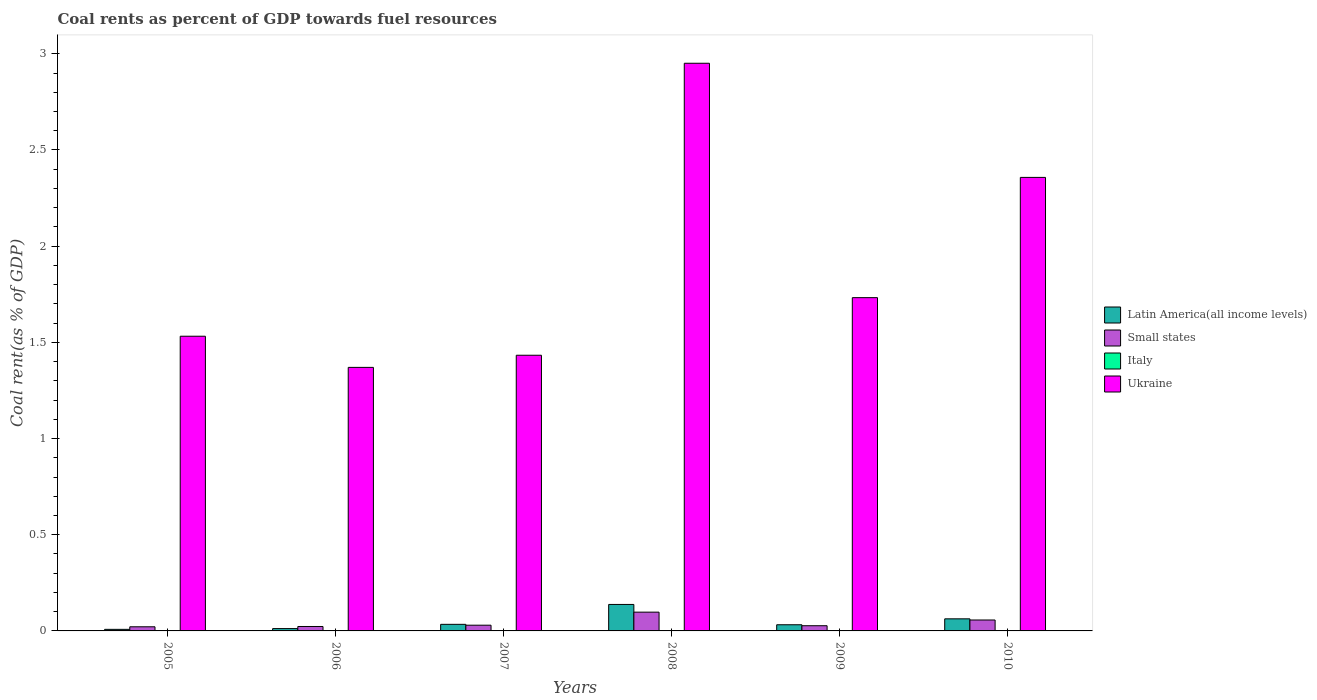How many different coloured bars are there?
Your answer should be compact. 4. How many groups of bars are there?
Give a very brief answer. 6. Are the number of bars on each tick of the X-axis equal?
Provide a short and direct response. Yes. How many bars are there on the 2nd tick from the right?
Make the answer very short. 4. What is the coal rent in Italy in 2010?
Keep it short and to the point. 0. Across all years, what is the maximum coal rent in Latin America(all income levels)?
Offer a terse response. 0.14. Across all years, what is the minimum coal rent in Italy?
Your answer should be very brief. 5.16849671469394e-6. What is the total coal rent in Italy in the graph?
Your response must be concise. 0. What is the difference between the coal rent in Latin America(all income levels) in 2005 and that in 2009?
Offer a very short reply. -0.02. What is the difference between the coal rent in Small states in 2010 and the coal rent in Latin America(all income levels) in 2009?
Offer a very short reply. 0.02. What is the average coal rent in Small states per year?
Offer a very short reply. 0.04. In the year 2005, what is the difference between the coal rent in Latin America(all income levels) and coal rent in Small states?
Give a very brief answer. -0.01. What is the ratio of the coal rent in Small states in 2006 to that in 2008?
Provide a succinct answer. 0.24. Is the coal rent in Ukraine in 2008 less than that in 2009?
Give a very brief answer. No. What is the difference between the highest and the second highest coal rent in Latin America(all income levels)?
Offer a terse response. 0.07. What is the difference between the highest and the lowest coal rent in Italy?
Offer a terse response. 0. Is the sum of the coal rent in Italy in 2005 and 2006 greater than the maximum coal rent in Ukraine across all years?
Offer a terse response. No. Is it the case that in every year, the sum of the coal rent in Latin America(all income levels) and coal rent in Small states is greater than the sum of coal rent in Ukraine and coal rent in Italy?
Your answer should be very brief. No. What does the 2nd bar from the left in 2008 represents?
Provide a succinct answer. Small states. What does the 1st bar from the right in 2007 represents?
Your answer should be compact. Ukraine. Is it the case that in every year, the sum of the coal rent in Ukraine and coal rent in Latin America(all income levels) is greater than the coal rent in Italy?
Offer a very short reply. Yes. How many bars are there?
Offer a terse response. 24. Are all the bars in the graph horizontal?
Ensure brevity in your answer.  No. Are the values on the major ticks of Y-axis written in scientific E-notation?
Your answer should be very brief. No. Where does the legend appear in the graph?
Make the answer very short. Center right. How many legend labels are there?
Your answer should be very brief. 4. What is the title of the graph?
Keep it short and to the point. Coal rents as percent of GDP towards fuel resources. What is the label or title of the X-axis?
Provide a succinct answer. Years. What is the label or title of the Y-axis?
Your answer should be very brief. Coal rent(as % of GDP). What is the Coal rent(as % of GDP) in Latin America(all income levels) in 2005?
Keep it short and to the point. 0.01. What is the Coal rent(as % of GDP) in Small states in 2005?
Provide a short and direct response. 0.02. What is the Coal rent(as % of GDP) of Italy in 2005?
Offer a very short reply. 1.52938665315344e-5. What is the Coal rent(as % of GDP) in Ukraine in 2005?
Provide a short and direct response. 1.53. What is the Coal rent(as % of GDP) in Latin America(all income levels) in 2006?
Offer a terse response. 0.01. What is the Coal rent(as % of GDP) of Small states in 2006?
Provide a succinct answer. 0.02. What is the Coal rent(as % of GDP) in Italy in 2006?
Provide a short and direct response. 5.16849671469394e-6. What is the Coal rent(as % of GDP) in Ukraine in 2006?
Your response must be concise. 1.37. What is the Coal rent(as % of GDP) in Latin America(all income levels) in 2007?
Your answer should be compact. 0.03. What is the Coal rent(as % of GDP) in Small states in 2007?
Provide a succinct answer. 0.03. What is the Coal rent(as % of GDP) in Italy in 2007?
Provide a succinct answer. 0. What is the Coal rent(as % of GDP) of Ukraine in 2007?
Offer a terse response. 1.43. What is the Coal rent(as % of GDP) of Latin America(all income levels) in 2008?
Give a very brief answer. 0.14. What is the Coal rent(as % of GDP) of Small states in 2008?
Your response must be concise. 0.1. What is the Coal rent(as % of GDP) in Italy in 2008?
Your answer should be compact. 0. What is the Coal rent(as % of GDP) in Ukraine in 2008?
Give a very brief answer. 2.95. What is the Coal rent(as % of GDP) in Latin America(all income levels) in 2009?
Your answer should be compact. 0.03. What is the Coal rent(as % of GDP) in Small states in 2009?
Ensure brevity in your answer.  0.03. What is the Coal rent(as % of GDP) in Italy in 2009?
Offer a terse response. 5.380155600468061e-5. What is the Coal rent(as % of GDP) of Ukraine in 2009?
Provide a succinct answer. 1.73. What is the Coal rent(as % of GDP) of Latin America(all income levels) in 2010?
Keep it short and to the point. 0.06. What is the Coal rent(as % of GDP) in Small states in 2010?
Make the answer very short. 0.06. What is the Coal rent(as % of GDP) of Italy in 2010?
Offer a terse response. 0. What is the Coal rent(as % of GDP) in Ukraine in 2010?
Give a very brief answer. 2.36. Across all years, what is the maximum Coal rent(as % of GDP) of Latin America(all income levels)?
Offer a very short reply. 0.14. Across all years, what is the maximum Coal rent(as % of GDP) in Small states?
Make the answer very short. 0.1. Across all years, what is the maximum Coal rent(as % of GDP) of Italy?
Offer a terse response. 0. Across all years, what is the maximum Coal rent(as % of GDP) in Ukraine?
Offer a terse response. 2.95. Across all years, what is the minimum Coal rent(as % of GDP) of Latin America(all income levels)?
Ensure brevity in your answer.  0.01. Across all years, what is the minimum Coal rent(as % of GDP) of Small states?
Offer a very short reply. 0.02. Across all years, what is the minimum Coal rent(as % of GDP) of Italy?
Your response must be concise. 5.16849671469394e-6. Across all years, what is the minimum Coal rent(as % of GDP) of Ukraine?
Your answer should be compact. 1.37. What is the total Coal rent(as % of GDP) in Latin America(all income levels) in the graph?
Provide a short and direct response. 0.29. What is the total Coal rent(as % of GDP) in Small states in the graph?
Keep it short and to the point. 0.26. What is the total Coal rent(as % of GDP) of Italy in the graph?
Provide a succinct answer. 0. What is the total Coal rent(as % of GDP) of Ukraine in the graph?
Offer a very short reply. 11.38. What is the difference between the Coal rent(as % of GDP) of Latin America(all income levels) in 2005 and that in 2006?
Your response must be concise. -0. What is the difference between the Coal rent(as % of GDP) in Small states in 2005 and that in 2006?
Make the answer very short. -0. What is the difference between the Coal rent(as % of GDP) in Ukraine in 2005 and that in 2006?
Give a very brief answer. 0.16. What is the difference between the Coal rent(as % of GDP) of Latin America(all income levels) in 2005 and that in 2007?
Provide a short and direct response. -0.03. What is the difference between the Coal rent(as % of GDP) of Small states in 2005 and that in 2007?
Keep it short and to the point. -0.01. What is the difference between the Coal rent(as % of GDP) of Italy in 2005 and that in 2007?
Give a very brief answer. -0. What is the difference between the Coal rent(as % of GDP) in Ukraine in 2005 and that in 2007?
Make the answer very short. 0.1. What is the difference between the Coal rent(as % of GDP) in Latin America(all income levels) in 2005 and that in 2008?
Your answer should be compact. -0.13. What is the difference between the Coal rent(as % of GDP) of Small states in 2005 and that in 2008?
Your response must be concise. -0.08. What is the difference between the Coal rent(as % of GDP) in Italy in 2005 and that in 2008?
Offer a very short reply. -0. What is the difference between the Coal rent(as % of GDP) in Ukraine in 2005 and that in 2008?
Offer a very short reply. -1.42. What is the difference between the Coal rent(as % of GDP) of Latin America(all income levels) in 2005 and that in 2009?
Your answer should be very brief. -0.02. What is the difference between the Coal rent(as % of GDP) in Small states in 2005 and that in 2009?
Offer a very short reply. -0.01. What is the difference between the Coal rent(as % of GDP) in Italy in 2005 and that in 2009?
Give a very brief answer. -0. What is the difference between the Coal rent(as % of GDP) in Ukraine in 2005 and that in 2009?
Give a very brief answer. -0.2. What is the difference between the Coal rent(as % of GDP) of Latin America(all income levels) in 2005 and that in 2010?
Provide a short and direct response. -0.05. What is the difference between the Coal rent(as % of GDP) in Small states in 2005 and that in 2010?
Ensure brevity in your answer.  -0.04. What is the difference between the Coal rent(as % of GDP) in Italy in 2005 and that in 2010?
Offer a terse response. -0. What is the difference between the Coal rent(as % of GDP) of Ukraine in 2005 and that in 2010?
Give a very brief answer. -0.83. What is the difference between the Coal rent(as % of GDP) of Latin America(all income levels) in 2006 and that in 2007?
Keep it short and to the point. -0.02. What is the difference between the Coal rent(as % of GDP) in Small states in 2006 and that in 2007?
Provide a short and direct response. -0.01. What is the difference between the Coal rent(as % of GDP) of Italy in 2006 and that in 2007?
Offer a very short reply. -0. What is the difference between the Coal rent(as % of GDP) in Ukraine in 2006 and that in 2007?
Ensure brevity in your answer.  -0.06. What is the difference between the Coal rent(as % of GDP) of Latin America(all income levels) in 2006 and that in 2008?
Ensure brevity in your answer.  -0.13. What is the difference between the Coal rent(as % of GDP) in Small states in 2006 and that in 2008?
Ensure brevity in your answer.  -0.07. What is the difference between the Coal rent(as % of GDP) in Italy in 2006 and that in 2008?
Offer a very short reply. -0. What is the difference between the Coal rent(as % of GDP) of Ukraine in 2006 and that in 2008?
Make the answer very short. -1.58. What is the difference between the Coal rent(as % of GDP) of Latin America(all income levels) in 2006 and that in 2009?
Give a very brief answer. -0.02. What is the difference between the Coal rent(as % of GDP) of Small states in 2006 and that in 2009?
Provide a short and direct response. -0. What is the difference between the Coal rent(as % of GDP) of Ukraine in 2006 and that in 2009?
Offer a terse response. -0.36. What is the difference between the Coal rent(as % of GDP) of Latin America(all income levels) in 2006 and that in 2010?
Your answer should be compact. -0.05. What is the difference between the Coal rent(as % of GDP) of Small states in 2006 and that in 2010?
Your answer should be compact. -0.03. What is the difference between the Coal rent(as % of GDP) of Italy in 2006 and that in 2010?
Keep it short and to the point. -0. What is the difference between the Coal rent(as % of GDP) of Ukraine in 2006 and that in 2010?
Give a very brief answer. -0.99. What is the difference between the Coal rent(as % of GDP) of Latin America(all income levels) in 2007 and that in 2008?
Give a very brief answer. -0.1. What is the difference between the Coal rent(as % of GDP) in Small states in 2007 and that in 2008?
Provide a succinct answer. -0.07. What is the difference between the Coal rent(as % of GDP) of Italy in 2007 and that in 2008?
Give a very brief answer. -0. What is the difference between the Coal rent(as % of GDP) in Ukraine in 2007 and that in 2008?
Offer a very short reply. -1.52. What is the difference between the Coal rent(as % of GDP) in Latin America(all income levels) in 2007 and that in 2009?
Provide a short and direct response. 0. What is the difference between the Coal rent(as % of GDP) in Small states in 2007 and that in 2009?
Keep it short and to the point. 0. What is the difference between the Coal rent(as % of GDP) in Ukraine in 2007 and that in 2009?
Your response must be concise. -0.3. What is the difference between the Coal rent(as % of GDP) in Latin America(all income levels) in 2007 and that in 2010?
Make the answer very short. -0.03. What is the difference between the Coal rent(as % of GDP) in Small states in 2007 and that in 2010?
Offer a terse response. -0.03. What is the difference between the Coal rent(as % of GDP) of Italy in 2007 and that in 2010?
Your response must be concise. -0. What is the difference between the Coal rent(as % of GDP) in Ukraine in 2007 and that in 2010?
Provide a short and direct response. -0.92. What is the difference between the Coal rent(as % of GDP) of Latin America(all income levels) in 2008 and that in 2009?
Give a very brief answer. 0.11. What is the difference between the Coal rent(as % of GDP) in Small states in 2008 and that in 2009?
Provide a succinct answer. 0.07. What is the difference between the Coal rent(as % of GDP) in Italy in 2008 and that in 2009?
Provide a succinct answer. 0. What is the difference between the Coal rent(as % of GDP) in Ukraine in 2008 and that in 2009?
Offer a terse response. 1.22. What is the difference between the Coal rent(as % of GDP) of Latin America(all income levels) in 2008 and that in 2010?
Your answer should be compact. 0.07. What is the difference between the Coal rent(as % of GDP) of Small states in 2008 and that in 2010?
Your response must be concise. 0.04. What is the difference between the Coal rent(as % of GDP) of Ukraine in 2008 and that in 2010?
Make the answer very short. 0.59. What is the difference between the Coal rent(as % of GDP) in Latin America(all income levels) in 2009 and that in 2010?
Offer a terse response. -0.03. What is the difference between the Coal rent(as % of GDP) in Small states in 2009 and that in 2010?
Offer a very short reply. -0.03. What is the difference between the Coal rent(as % of GDP) of Italy in 2009 and that in 2010?
Your response must be concise. -0. What is the difference between the Coal rent(as % of GDP) of Ukraine in 2009 and that in 2010?
Your answer should be compact. -0.63. What is the difference between the Coal rent(as % of GDP) of Latin America(all income levels) in 2005 and the Coal rent(as % of GDP) of Small states in 2006?
Ensure brevity in your answer.  -0.01. What is the difference between the Coal rent(as % of GDP) of Latin America(all income levels) in 2005 and the Coal rent(as % of GDP) of Italy in 2006?
Your answer should be compact. 0.01. What is the difference between the Coal rent(as % of GDP) in Latin America(all income levels) in 2005 and the Coal rent(as % of GDP) in Ukraine in 2006?
Ensure brevity in your answer.  -1.36. What is the difference between the Coal rent(as % of GDP) of Small states in 2005 and the Coal rent(as % of GDP) of Italy in 2006?
Your answer should be very brief. 0.02. What is the difference between the Coal rent(as % of GDP) of Small states in 2005 and the Coal rent(as % of GDP) of Ukraine in 2006?
Your answer should be very brief. -1.35. What is the difference between the Coal rent(as % of GDP) of Italy in 2005 and the Coal rent(as % of GDP) of Ukraine in 2006?
Your response must be concise. -1.37. What is the difference between the Coal rent(as % of GDP) in Latin America(all income levels) in 2005 and the Coal rent(as % of GDP) in Small states in 2007?
Offer a terse response. -0.02. What is the difference between the Coal rent(as % of GDP) in Latin America(all income levels) in 2005 and the Coal rent(as % of GDP) in Italy in 2007?
Offer a terse response. 0.01. What is the difference between the Coal rent(as % of GDP) in Latin America(all income levels) in 2005 and the Coal rent(as % of GDP) in Ukraine in 2007?
Offer a very short reply. -1.42. What is the difference between the Coal rent(as % of GDP) in Small states in 2005 and the Coal rent(as % of GDP) in Italy in 2007?
Make the answer very short. 0.02. What is the difference between the Coal rent(as % of GDP) of Small states in 2005 and the Coal rent(as % of GDP) of Ukraine in 2007?
Offer a terse response. -1.41. What is the difference between the Coal rent(as % of GDP) in Italy in 2005 and the Coal rent(as % of GDP) in Ukraine in 2007?
Provide a succinct answer. -1.43. What is the difference between the Coal rent(as % of GDP) of Latin America(all income levels) in 2005 and the Coal rent(as % of GDP) of Small states in 2008?
Keep it short and to the point. -0.09. What is the difference between the Coal rent(as % of GDP) of Latin America(all income levels) in 2005 and the Coal rent(as % of GDP) of Italy in 2008?
Give a very brief answer. 0.01. What is the difference between the Coal rent(as % of GDP) of Latin America(all income levels) in 2005 and the Coal rent(as % of GDP) of Ukraine in 2008?
Offer a terse response. -2.94. What is the difference between the Coal rent(as % of GDP) of Small states in 2005 and the Coal rent(as % of GDP) of Italy in 2008?
Provide a short and direct response. 0.02. What is the difference between the Coal rent(as % of GDP) of Small states in 2005 and the Coal rent(as % of GDP) of Ukraine in 2008?
Your answer should be very brief. -2.93. What is the difference between the Coal rent(as % of GDP) of Italy in 2005 and the Coal rent(as % of GDP) of Ukraine in 2008?
Make the answer very short. -2.95. What is the difference between the Coal rent(as % of GDP) in Latin America(all income levels) in 2005 and the Coal rent(as % of GDP) in Small states in 2009?
Offer a very short reply. -0.02. What is the difference between the Coal rent(as % of GDP) of Latin America(all income levels) in 2005 and the Coal rent(as % of GDP) of Italy in 2009?
Your answer should be very brief. 0.01. What is the difference between the Coal rent(as % of GDP) of Latin America(all income levels) in 2005 and the Coal rent(as % of GDP) of Ukraine in 2009?
Provide a short and direct response. -1.72. What is the difference between the Coal rent(as % of GDP) of Small states in 2005 and the Coal rent(as % of GDP) of Italy in 2009?
Offer a very short reply. 0.02. What is the difference between the Coal rent(as % of GDP) of Small states in 2005 and the Coal rent(as % of GDP) of Ukraine in 2009?
Give a very brief answer. -1.71. What is the difference between the Coal rent(as % of GDP) in Italy in 2005 and the Coal rent(as % of GDP) in Ukraine in 2009?
Offer a very short reply. -1.73. What is the difference between the Coal rent(as % of GDP) in Latin America(all income levels) in 2005 and the Coal rent(as % of GDP) in Small states in 2010?
Give a very brief answer. -0.05. What is the difference between the Coal rent(as % of GDP) of Latin America(all income levels) in 2005 and the Coal rent(as % of GDP) of Italy in 2010?
Your answer should be compact. 0.01. What is the difference between the Coal rent(as % of GDP) of Latin America(all income levels) in 2005 and the Coal rent(as % of GDP) of Ukraine in 2010?
Your response must be concise. -2.35. What is the difference between the Coal rent(as % of GDP) in Small states in 2005 and the Coal rent(as % of GDP) in Italy in 2010?
Provide a succinct answer. 0.02. What is the difference between the Coal rent(as % of GDP) of Small states in 2005 and the Coal rent(as % of GDP) of Ukraine in 2010?
Provide a short and direct response. -2.34. What is the difference between the Coal rent(as % of GDP) of Italy in 2005 and the Coal rent(as % of GDP) of Ukraine in 2010?
Offer a very short reply. -2.36. What is the difference between the Coal rent(as % of GDP) of Latin America(all income levels) in 2006 and the Coal rent(as % of GDP) of Small states in 2007?
Your response must be concise. -0.02. What is the difference between the Coal rent(as % of GDP) in Latin America(all income levels) in 2006 and the Coal rent(as % of GDP) in Italy in 2007?
Make the answer very short. 0.01. What is the difference between the Coal rent(as % of GDP) in Latin America(all income levels) in 2006 and the Coal rent(as % of GDP) in Ukraine in 2007?
Ensure brevity in your answer.  -1.42. What is the difference between the Coal rent(as % of GDP) of Small states in 2006 and the Coal rent(as % of GDP) of Italy in 2007?
Make the answer very short. 0.02. What is the difference between the Coal rent(as % of GDP) in Small states in 2006 and the Coal rent(as % of GDP) in Ukraine in 2007?
Make the answer very short. -1.41. What is the difference between the Coal rent(as % of GDP) of Italy in 2006 and the Coal rent(as % of GDP) of Ukraine in 2007?
Provide a short and direct response. -1.43. What is the difference between the Coal rent(as % of GDP) of Latin America(all income levels) in 2006 and the Coal rent(as % of GDP) of Small states in 2008?
Offer a very short reply. -0.09. What is the difference between the Coal rent(as % of GDP) in Latin America(all income levels) in 2006 and the Coal rent(as % of GDP) in Italy in 2008?
Make the answer very short. 0.01. What is the difference between the Coal rent(as % of GDP) of Latin America(all income levels) in 2006 and the Coal rent(as % of GDP) of Ukraine in 2008?
Your response must be concise. -2.94. What is the difference between the Coal rent(as % of GDP) in Small states in 2006 and the Coal rent(as % of GDP) in Italy in 2008?
Offer a terse response. 0.02. What is the difference between the Coal rent(as % of GDP) in Small states in 2006 and the Coal rent(as % of GDP) in Ukraine in 2008?
Provide a short and direct response. -2.93. What is the difference between the Coal rent(as % of GDP) in Italy in 2006 and the Coal rent(as % of GDP) in Ukraine in 2008?
Give a very brief answer. -2.95. What is the difference between the Coal rent(as % of GDP) of Latin America(all income levels) in 2006 and the Coal rent(as % of GDP) of Small states in 2009?
Provide a short and direct response. -0.01. What is the difference between the Coal rent(as % of GDP) of Latin America(all income levels) in 2006 and the Coal rent(as % of GDP) of Italy in 2009?
Make the answer very short. 0.01. What is the difference between the Coal rent(as % of GDP) in Latin America(all income levels) in 2006 and the Coal rent(as % of GDP) in Ukraine in 2009?
Your response must be concise. -1.72. What is the difference between the Coal rent(as % of GDP) of Small states in 2006 and the Coal rent(as % of GDP) of Italy in 2009?
Offer a very short reply. 0.02. What is the difference between the Coal rent(as % of GDP) of Small states in 2006 and the Coal rent(as % of GDP) of Ukraine in 2009?
Your response must be concise. -1.71. What is the difference between the Coal rent(as % of GDP) of Italy in 2006 and the Coal rent(as % of GDP) of Ukraine in 2009?
Give a very brief answer. -1.73. What is the difference between the Coal rent(as % of GDP) in Latin America(all income levels) in 2006 and the Coal rent(as % of GDP) in Small states in 2010?
Offer a terse response. -0.04. What is the difference between the Coal rent(as % of GDP) in Latin America(all income levels) in 2006 and the Coal rent(as % of GDP) in Italy in 2010?
Ensure brevity in your answer.  0.01. What is the difference between the Coal rent(as % of GDP) of Latin America(all income levels) in 2006 and the Coal rent(as % of GDP) of Ukraine in 2010?
Your response must be concise. -2.35. What is the difference between the Coal rent(as % of GDP) of Small states in 2006 and the Coal rent(as % of GDP) of Italy in 2010?
Your response must be concise. 0.02. What is the difference between the Coal rent(as % of GDP) of Small states in 2006 and the Coal rent(as % of GDP) of Ukraine in 2010?
Ensure brevity in your answer.  -2.33. What is the difference between the Coal rent(as % of GDP) in Italy in 2006 and the Coal rent(as % of GDP) in Ukraine in 2010?
Ensure brevity in your answer.  -2.36. What is the difference between the Coal rent(as % of GDP) in Latin America(all income levels) in 2007 and the Coal rent(as % of GDP) in Small states in 2008?
Provide a short and direct response. -0.06. What is the difference between the Coal rent(as % of GDP) of Latin America(all income levels) in 2007 and the Coal rent(as % of GDP) of Italy in 2008?
Your response must be concise. 0.03. What is the difference between the Coal rent(as % of GDP) in Latin America(all income levels) in 2007 and the Coal rent(as % of GDP) in Ukraine in 2008?
Your response must be concise. -2.92. What is the difference between the Coal rent(as % of GDP) of Small states in 2007 and the Coal rent(as % of GDP) of Italy in 2008?
Provide a succinct answer. 0.03. What is the difference between the Coal rent(as % of GDP) in Small states in 2007 and the Coal rent(as % of GDP) in Ukraine in 2008?
Offer a very short reply. -2.92. What is the difference between the Coal rent(as % of GDP) in Italy in 2007 and the Coal rent(as % of GDP) in Ukraine in 2008?
Ensure brevity in your answer.  -2.95. What is the difference between the Coal rent(as % of GDP) in Latin America(all income levels) in 2007 and the Coal rent(as % of GDP) in Small states in 2009?
Provide a short and direct response. 0.01. What is the difference between the Coal rent(as % of GDP) of Latin America(all income levels) in 2007 and the Coal rent(as % of GDP) of Italy in 2009?
Ensure brevity in your answer.  0.03. What is the difference between the Coal rent(as % of GDP) of Latin America(all income levels) in 2007 and the Coal rent(as % of GDP) of Ukraine in 2009?
Keep it short and to the point. -1.7. What is the difference between the Coal rent(as % of GDP) of Small states in 2007 and the Coal rent(as % of GDP) of Italy in 2009?
Your answer should be compact. 0.03. What is the difference between the Coal rent(as % of GDP) of Small states in 2007 and the Coal rent(as % of GDP) of Ukraine in 2009?
Give a very brief answer. -1.7. What is the difference between the Coal rent(as % of GDP) of Italy in 2007 and the Coal rent(as % of GDP) of Ukraine in 2009?
Your answer should be compact. -1.73. What is the difference between the Coal rent(as % of GDP) of Latin America(all income levels) in 2007 and the Coal rent(as % of GDP) of Small states in 2010?
Your answer should be compact. -0.02. What is the difference between the Coal rent(as % of GDP) of Latin America(all income levels) in 2007 and the Coal rent(as % of GDP) of Italy in 2010?
Keep it short and to the point. 0.03. What is the difference between the Coal rent(as % of GDP) in Latin America(all income levels) in 2007 and the Coal rent(as % of GDP) in Ukraine in 2010?
Offer a terse response. -2.32. What is the difference between the Coal rent(as % of GDP) in Small states in 2007 and the Coal rent(as % of GDP) in Italy in 2010?
Ensure brevity in your answer.  0.03. What is the difference between the Coal rent(as % of GDP) of Small states in 2007 and the Coal rent(as % of GDP) of Ukraine in 2010?
Keep it short and to the point. -2.33. What is the difference between the Coal rent(as % of GDP) of Italy in 2007 and the Coal rent(as % of GDP) of Ukraine in 2010?
Your response must be concise. -2.36. What is the difference between the Coal rent(as % of GDP) of Latin America(all income levels) in 2008 and the Coal rent(as % of GDP) of Small states in 2009?
Your answer should be compact. 0.11. What is the difference between the Coal rent(as % of GDP) of Latin America(all income levels) in 2008 and the Coal rent(as % of GDP) of Italy in 2009?
Your answer should be very brief. 0.14. What is the difference between the Coal rent(as % of GDP) in Latin America(all income levels) in 2008 and the Coal rent(as % of GDP) in Ukraine in 2009?
Provide a short and direct response. -1.59. What is the difference between the Coal rent(as % of GDP) in Small states in 2008 and the Coal rent(as % of GDP) in Italy in 2009?
Give a very brief answer. 0.1. What is the difference between the Coal rent(as % of GDP) in Small states in 2008 and the Coal rent(as % of GDP) in Ukraine in 2009?
Keep it short and to the point. -1.63. What is the difference between the Coal rent(as % of GDP) of Italy in 2008 and the Coal rent(as % of GDP) of Ukraine in 2009?
Your answer should be compact. -1.73. What is the difference between the Coal rent(as % of GDP) in Latin America(all income levels) in 2008 and the Coal rent(as % of GDP) in Small states in 2010?
Give a very brief answer. 0.08. What is the difference between the Coal rent(as % of GDP) of Latin America(all income levels) in 2008 and the Coal rent(as % of GDP) of Italy in 2010?
Ensure brevity in your answer.  0.14. What is the difference between the Coal rent(as % of GDP) in Latin America(all income levels) in 2008 and the Coal rent(as % of GDP) in Ukraine in 2010?
Offer a very short reply. -2.22. What is the difference between the Coal rent(as % of GDP) of Small states in 2008 and the Coal rent(as % of GDP) of Italy in 2010?
Your answer should be compact. 0.1. What is the difference between the Coal rent(as % of GDP) in Small states in 2008 and the Coal rent(as % of GDP) in Ukraine in 2010?
Your answer should be compact. -2.26. What is the difference between the Coal rent(as % of GDP) of Italy in 2008 and the Coal rent(as % of GDP) of Ukraine in 2010?
Ensure brevity in your answer.  -2.36. What is the difference between the Coal rent(as % of GDP) in Latin America(all income levels) in 2009 and the Coal rent(as % of GDP) in Small states in 2010?
Give a very brief answer. -0.02. What is the difference between the Coal rent(as % of GDP) of Latin America(all income levels) in 2009 and the Coal rent(as % of GDP) of Italy in 2010?
Offer a terse response. 0.03. What is the difference between the Coal rent(as % of GDP) of Latin America(all income levels) in 2009 and the Coal rent(as % of GDP) of Ukraine in 2010?
Your answer should be compact. -2.33. What is the difference between the Coal rent(as % of GDP) of Small states in 2009 and the Coal rent(as % of GDP) of Italy in 2010?
Offer a terse response. 0.03. What is the difference between the Coal rent(as % of GDP) in Small states in 2009 and the Coal rent(as % of GDP) in Ukraine in 2010?
Keep it short and to the point. -2.33. What is the difference between the Coal rent(as % of GDP) in Italy in 2009 and the Coal rent(as % of GDP) in Ukraine in 2010?
Provide a succinct answer. -2.36. What is the average Coal rent(as % of GDP) in Latin America(all income levels) per year?
Make the answer very short. 0.05. What is the average Coal rent(as % of GDP) of Small states per year?
Provide a succinct answer. 0.04. What is the average Coal rent(as % of GDP) in Ukraine per year?
Give a very brief answer. 1.9. In the year 2005, what is the difference between the Coal rent(as % of GDP) of Latin America(all income levels) and Coal rent(as % of GDP) of Small states?
Keep it short and to the point. -0.01. In the year 2005, what is the difference between the Coal rent(as % of GDP) in Latin America(all income levels) and Coal rent(as % of GDP) in Italy?
Give a very brief answer. 0.01. In the year 2005, what is the difference between the Coal rent(as % of GDP) of Latin America(all income levels) and Coal rent(as % of GDP) of Ukraine?
Your answer should be compact. -1.52. In the year 2005, what is the difference between the Coal rent(as % of GDP) of Small states and Coal rent(as % of GDP) of Italy?
Your response must be concise. 0.02. In the year 2005, what is the difference between the Coal rent(as % of GDP) in Small states and Coal rent(as % of GDP) in Ukraine?
Your response must be concise. -1.51. In the year 2005, what is the difference between the Coal rent(as % of GDP) in Italy and Coal rent(as % of GDP) in Ukraine?
Give a very brief answer. -1.53. In the year 2006, what is the difference between the Coal rent(as % of GDP) in Latin America(all income levels) and Coal rent(as % of GDP) in Small states?
Offer a terse response. -0.01. In the year 2006, what is the difference between the Coal rent(as % of GDP) of Latin America(all income levels) and Coal rent(as % of GDP) of Italy?
Your answer should be compact. 0.01. In the year 2006, what is the difference between the Coal rent(as % of GDP) of Latin America(all income levels) and Coal rent(as % of GDP) of Ukraine?
Give a very brief answer. -1.36. In the year 2006, what is the difference between the Coal rent(as % of GDP) of Small states and Coal rent(as % of GDP) of Italy?
Make the answer very short. 0.02. In the year 2006, what is the difference between the Coal rent(as % of GDP) of Small states and Coal rent(as % of GDP) of Ukraine?
Ensure brevity in your answer.  -1.35. In the year 2006, what is the difference between the Coal rent(as % of GDP) in Italy and Coal rent(as % of GDP) in Ukraine?
Provide a short and direct response. -1.37. In the year 2007, what is the difference between the Coal rent(as % of GDP) of Latin America(all income levels) and Coal rent(as % of GDP) of Small states?
Your answer should be very brief. 0. In the year 2007, what is the difference between the Coal rent(as % of GDP) in Latin America(all income levels) and Coal rent(as % of GDP) in Italy?
Keep it short and to the point. 0.03. In the year 2007, what is the difference between the Coal rent(as % of GDP) in Latin America(all income levels) and Coal rent(as % of GDP) in Ukraine?
Offer a very short reply. -1.4. In the year 2007, what is the difference between the Coal rent(as % of GDP) in Small states and Coal rent(as % of GDP) in Italy?
Offer a very short reply. 0.03. In the year 2007, what is the difference between the Coal rent(as % of GDP) in Small states and Coal rent(as % of GDP) in Ukraine?
Provide a short and direct response. -1.4. In the year 2007, what is the difference between the Coal rent(as % of GDP) in Italy and Coal rent(as % of GDP) in Ukraine?
Make the answer very short. -1.43. In the year 2008, what is the difference between the Coal rent(as % of GDP) of Latin America(all income levels) and Coal rent(as % of GDP) of Italy?
Offer a very short reply. 0.14. In the year 2008, what is the difference between the Coal rent(as % of GDP) in Latin America(all income levels) and Coal rent(as % of GDP) in Ukraine?
Ensure brevity in your answer.  -2.81. In the year 2008, what is the difference between the Coal rent(as % of GDP) of Small states and Coal rent(as % of GDP) of Italy?
Provide a succinct answer. 0.1. In the year 2008, what is the difference between the Coal rent(as % of GDP) in Small states and Coal rent(as % of GDP) in Ukraine?
Provide a succinct answer. -2.85. In the year 2008, what is the difference between the Coal rent(as % of GDP) in Italy and Coal rent(as % of GDP) in Ukraine?
Offer a very short reply. -2.95. In the year 2009, what is the difference between the Coal rent(as % of GDP) in Latin America(all income levels) and Coal rent(as % of GDP) in Small states?
Your response must be concise. 0.01. In the year 2009, what is the difference between the Coal rent(as % of GDP) of Latin America(all income levels) and Coal rent(as % of GDP) of Italy?
Provide a short and direct response. 0.03. In the year 2009, what is the difference between the Coal rent(as % of GDP) in Latin America(all income levels) and Coal rent(as % of GDP) in Ukraine?
Ensure brevity in your answer.  -1.7. In the year 2009, what is the difference between the Coal rent(as % of GDP) in Small states and Coal rent(as % of GDP) in Italy?
Your answer should be compact. 0.03. In the year 2009, what is the difference between the Coal rent(as % of GDP) in Small states and Coal rent(as % of GDP) in Ukraine?
Make the answer very short. -1.71. In the year 2009, what is the difference between the Coal rent(as % of GDP) of Italy and Coal rent(as % of GDP) of Ukraine?
Offer a very short reply. -1.73. In the year 2010, what is the difference between the Coal rent(as % of GDP) of Latin America(all income levels) and Coal rent(as % of GDP) of Small states?
Make the answer very short. 0.01. In the year 2010, what is the difference between the Coal rent(as % of GDP) of Latin America(all income levels) and Coal rent(as % of GDP) of Italy?
Your response must be concise. 0.06. In the year 2010, what is the difference between the Coal rent(as % of GDP) of Latin America(all income levels) and Coal rent(as % of GDP) of Ukraine?
Your answer should be compact. -2.29. In the year 2010, what is the difference between the Coal rent(as % of GDP) of Small states and Coal rent(as % of GDP) of Italy?
Your answer should be very brief. 0.06. In the year 2010, what is the difference between the Coal rent(as % of GDP) in Small states and Coal rent(as % of GDP) in Ukraine?
Keep it short and to the point. -2.3. In the year 2010, what is the difference between the Coal rent(as % of GDP) of Italy and Coal rent(as % of GDP) of Ukraine?
Provide a short and direct response. -2.36. What is the ratio of the Coal rent(as % of GDP) in Latin America(all income levels) in 2005 to that in 2006?
Ensure brevity in your answer.  0.67. What is the ratio of the Coal rent(as % of GDP) of Small states in 2005 to that in 2006?
Ensure brevity in your answer.  0.93. What is the ratio of the Coal rent(as % of GDP) of Italy in 2005 to that in 2006?
Keep it short and to the point. 2.96. What is the ratio of the Coal rent(as % of GDP) of Ukraine in 2005 to that in 2006?
Offer a very short reply. 1.12. What is the ratio of the Coal rent(as % of GDP) of Latin America(all income levels) in 2005 to that in 2007?
Your answer should be compact. 0.24. What is the ratio of the Coal rent(as % of GDP) of Small states in 2005 to that in 2007?
Give a very brief answer. 0.72. What is the ratio of the Coal rent(as % of GDP) of Italy in 2005 to that in 2007?
Offer a very short reply. 0.14. What is the ratio of the Coal rent(as % of GDP) in Ukraine in 2005 to that in 2007?
Ensure brevity in your answer.  1.07. What is the ratio of the Coal rent(as % of GDP) of Latin America(all income levels) in 2005 to that in 2008?
Offer a very short reply. 0.06. What is the ratio of the Coal rent(as % of GDP) of Small states in 2005 to that in 2008?
Offer a very short reply. 0.22. What is the ratio of the Coal rent(as % of GDP) of Italy in 2005 to that in 2008?
Provide a succinct answer. 0.04. What is the ratio of the Coal rent(as % of GDP) in Ukraine in 2005 to that in 2008?
Provide a short and direct response. 0.52. What is the ratio of the Coal rent(as % of GDP) in Latin America(all income levels) in 2005 to that in 2009?
Your response must be concise. 0.26. What is the ratio of the Coal rent(as % of GDP) of Small states in 2005 to that in 2009?
Your answer should be compact. 0.8. What is the ratio of the Coal rent(as % of GDP) of Italy in 2005 to that in 2009?
Offer a terse response. 0.28. What is the ratio of the Coal rent(as % of GDP) of Ukraine in 2005 to that in 2009?
Offer a terse response. 0.88. What is the ratio of the Coal rent(as % of GDP) in Latin America(all income levels) in 2005 to that in 2010?
Keep it short and to the point. 0.13. What is the ratio of the Coal rent(as % of GDP) in Small states in 2005 to that in 2010?
Make the answer very short. 0.38. What is the ratio of the Coal rent(as % of GDP) of Italy in 2005 to that in 2010?
Make the answer very short. 0.08. What is the ratio of the Coal rent(as % of GDP) of Ukraine in 2005 to that in 2010?
Offer a terse response. 0.65. What is the ratio of the Coal rent(as % of GDP) in Latin America(all income levels) in 2006 to that in 2007?
Keep it short and to the point. 0.36. What is the ratio of the Coal rent(as % of GDP) of Small states in 2006 to that in 2007?
Your answer should be very brief. 0.77. What is the ratio of the Coal rent(as % of GDP) in Italy in 2006 to that in 2007?
Provide a short and direct response. 0.05. What is the ratio of the Coal rent(as % of GDP) of Ukraine in 2006 to that in 2007?
Your answer should be very brief. 0.96. What is the ratio of the Coal rent(as % of GDP) of Latin America(all income levels) in 2006 to that in 2008?
Your response must be concise. 0.09. What is the ratio of the Coal rent(as % of GDP) of Small states in 2006 to that in 2008?
Your answer should be compact. 0.24. What is the ratio of the Coal rent(as % of GDP) of Italy in 2006 to that in 2008?
Offer a terse response. 0.01. What is the ratio of the Coal rent(as % of GDP) in Ukraine in 2006 to that in 2008?
Your answer should be very brief. 0.46. What is the ratio of the Coal rent(as % of GDP) in Latin America(all income levels) in 2006 to that in 2009?
Your answer should be compact. 0.38. What is the ratio of the Coal rent(as % of GDP) of Small states in 2006 to that in 2009?
Your answer should be compact. 0.85. What is the ratio of the Coal rent(as % of GDP) of Italy in 2006 to that in 2009?
Offer a very short reply. 0.1. What is the ratio of the Coal rent(as % of GDP) in Ukraine in 2006 to that in 2009?
Provide a succinct answer. 0.79. What is the ratio of the Coal rent(as % of GDP) in Latin America(all income levels) in 2006 to that in 2010?
Your response must be concise. 0.19. What is the ratio of the Coal rent(as % of GDP) in Small states in 2006 to that in 2010?
Offer a terse response. 0.41. What is the ratio of the Coal rent(as % of GDP) in Italy in 2006 to that in 2010?
Your response must be concise. 0.03. What is the ratio of the Coal rent(as % of GDP) in Ukraine in 2006 to that in 2010?
Your answer should be compact. 0.58. What is the ratio of the Coal rent(as % of GDP) in Latin America(all income levels) in 2007 to that in 2008?
Keep it short and to the point. 0.25. What is the ratio of the Coal rent(as % of GDP) in Small states in 2007 to that in 2008?
Your answer should be compact. 0.31. What is the ratio of the Coal rent(as % of GDP) in Italy in 2007 to that in 2008?
Ensure brevity in your answer.  0.32. What is the ratio of the Coal rent(as % of GDP) of Ukraine in 2007 to that in 2008?
Give a very brief answer. 0.49. What is the ratio of the Coal rent(as % of GDP) of Latin America(all income levels) in 2007 to that in 2009?
Offer a very short reply. 1.07. What is the ratio of the Coal rent(as % of GDP) in Small states in 2007 to that in 2009?
Your answer should be compact. 1.1. What is the ratio of the Coal rent(as % of GDP) in Italy in 2007 to that in 2009?
Your response must be concise. 2.07. What is the ratio of the Coal rent(as % of GDP) in Ukraine in 2007 to that in 2009?
Offer a terse response. 0.83. What is the ratio of the Coal rent(as % of GDP) of Latin America(all income levels) in 2007 to that in 2010?
Keep it short and to the point. 0.54. What is the ratio of the Coal rent(as % of GDP) in Small states in 2007 to that in 2010?
Your response must be concise. 0.52. What is the ratio of the Coal rent(as % of GDP) in Italy in 2007 to that in 2010?
Your answer should be compact. 0.6. What is the ratio of the Coal rent(as % of GDP) of Ukraine in 2007 to that in 2010?
Keep it short and to the point. 0.61. What is the ratio of the Coal rent(as % of GDP) in Latin America(all income levels) in 2008 to that in 2009?
Your response must be concise. 4.3. What is the ratio of the Coal rent(as % of GDP) of Small states in 2008 to that in 2009?
Give a very brief answer. 3.61. What is the ratio of the Coal rent(as % of GDP) in Italy in 2008 to that in 2009?
Provide a short and direct response. 6.54. What is the ratio of the Coal rent(as % of GDP) of Ukraine in 2008 to that in 2009?
Provide a short and direct response. 1.7. What is the ratio of the Coal rent(as % of GDP) in Latin America(all income levels) in 2008 to that in 2010?
Offer a terse response. 2.19. What is the ratio of the Coal rent(as % of GDP) of Small states in 2008 to that in 2010?
Your answer should be very brief. 1.72. What is the ratio of the Coal rent(as % of GDP) of Italy in 2008 to that in 2010?
Provide a succinct answer. 1.89. What is the ratio of the Coal rent(as % of GDP) in Ukraine in 2008 to that in 2010?
Make the answer very short. 1.25. What is the ratio of the Coal rent(as % of GDP) of Latin America(all income levels) in 2009 to that in 2010?
Your response must be concise. 0.51. What is the ratio of the Coal rent(as % of GDP) in Small states in 2009 to that in 2010?
Your answer should be compact. 0.48. What is the ratio of the Coal rent(as % of GDP) in Italy in 2009 to that in 2010?
Provide a short and direct response. 0.29. What is the ratio of the Coal rent(as % of GDP) of Ukraine in 2009 to that in 2010?
Make the answer very short. 0.73. What is the difference between the highest and the second highest Coal rent(as % of GDP) in Latin America(all income levels)?
Keep it short and to the point. 0.07. What is the difference between the highest and the second highest Coal rent(as % of GDP) of Small states?
Offer a terse response. 0.04. What is the difference between the highest and the second highest Coal rent(as % of GDP) in Italy?
Provide a short and direct response. 0. What is the difference between the highest and the second highest Coal rent(as % of GDP) in Ukraine?
Keep it short and to the point. 0.59. What is the difference between the highest and the lowest Coal rent(as % of GDP) of Latin America(all income levels)?
Give a very brief answer. 0.13. What is the difference between the highest and the lowest Coal rent(as % of GDP) in Small states?
Provide a short and direct response. 0.08. What is the difference between the highest and the lowest Coal rent(as % of GDP) of Ukraine?
Make the answer very short. 1.58. 